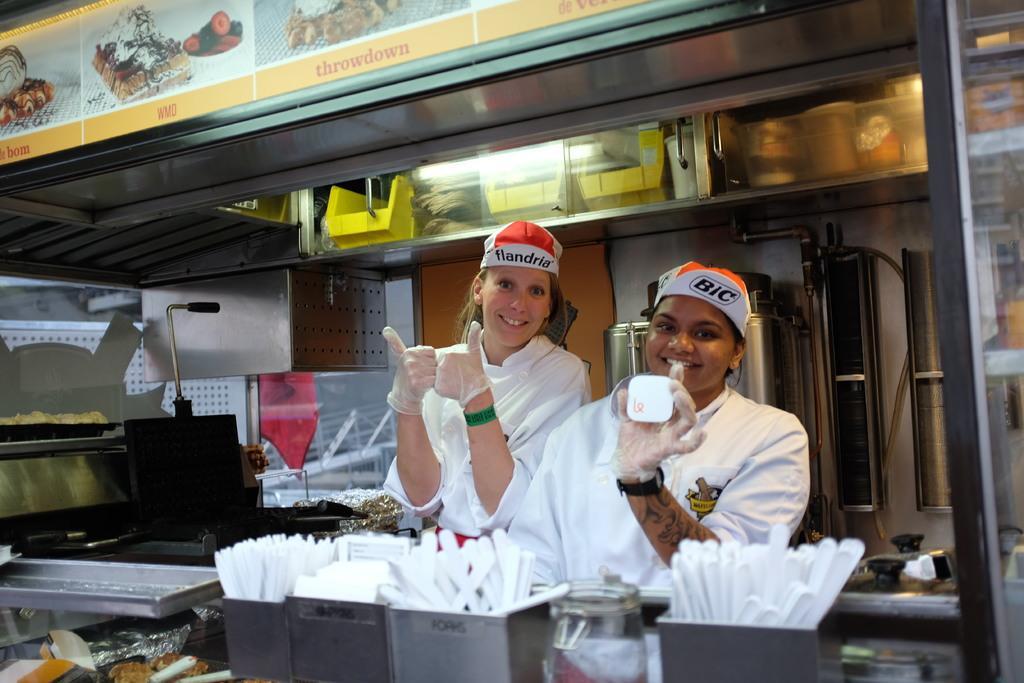In one or two sentences, can you explain what this image depicts? In this picture there are two women wearing white dress and there are few spoons and some other objects in front of them and there is a image of few eatables placed in the left top corner and there are some other objects in the background. 